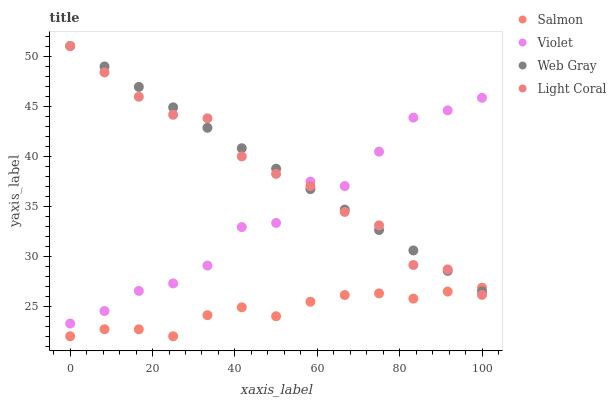Does Salmon have the minimum area under the curve?
Answer yes or no. Yes. Does Web Gray have the maximum area under the curve?
Answer yes or no. Yes. Does Web Gray have the minimum area under the curve?
Answer yes or no. No. Does Salmon have the maximum area under the curve?
Answer yes or no. No. Is Web Gray the smoothest?
Answer yes or no. Yes. Is Violet the roughest?
Answer yes or no. Yes. Is Salmon the smoothest?
Answer yes or no. No. Is Salmon the roughest?
Answer yes or no. No. Does Salmon have the lowest value?
Answer yes or no. Yes. Does Web Gray have the lowest value?
Answer yes or no. No. Does Web Gray have the highest value?
Answer yes or no. Yes. Does Salmon have the highest value?
Answer yes or no. No. Is Salmon less than Violet?
Answer yes or no. Yes. Is Violet greater than Salmon?
Answer yes or no. Yes. Does Light Coral intersect Web Gray?
Answer yes or no. Yes. Is Light Coral less than Web Gray?
Answer yes or no. No. Is Light Coral greater than Web Gray?
Answer yes or no. No. Does Salmon intersect Violet?
Answer yes or no. No. 